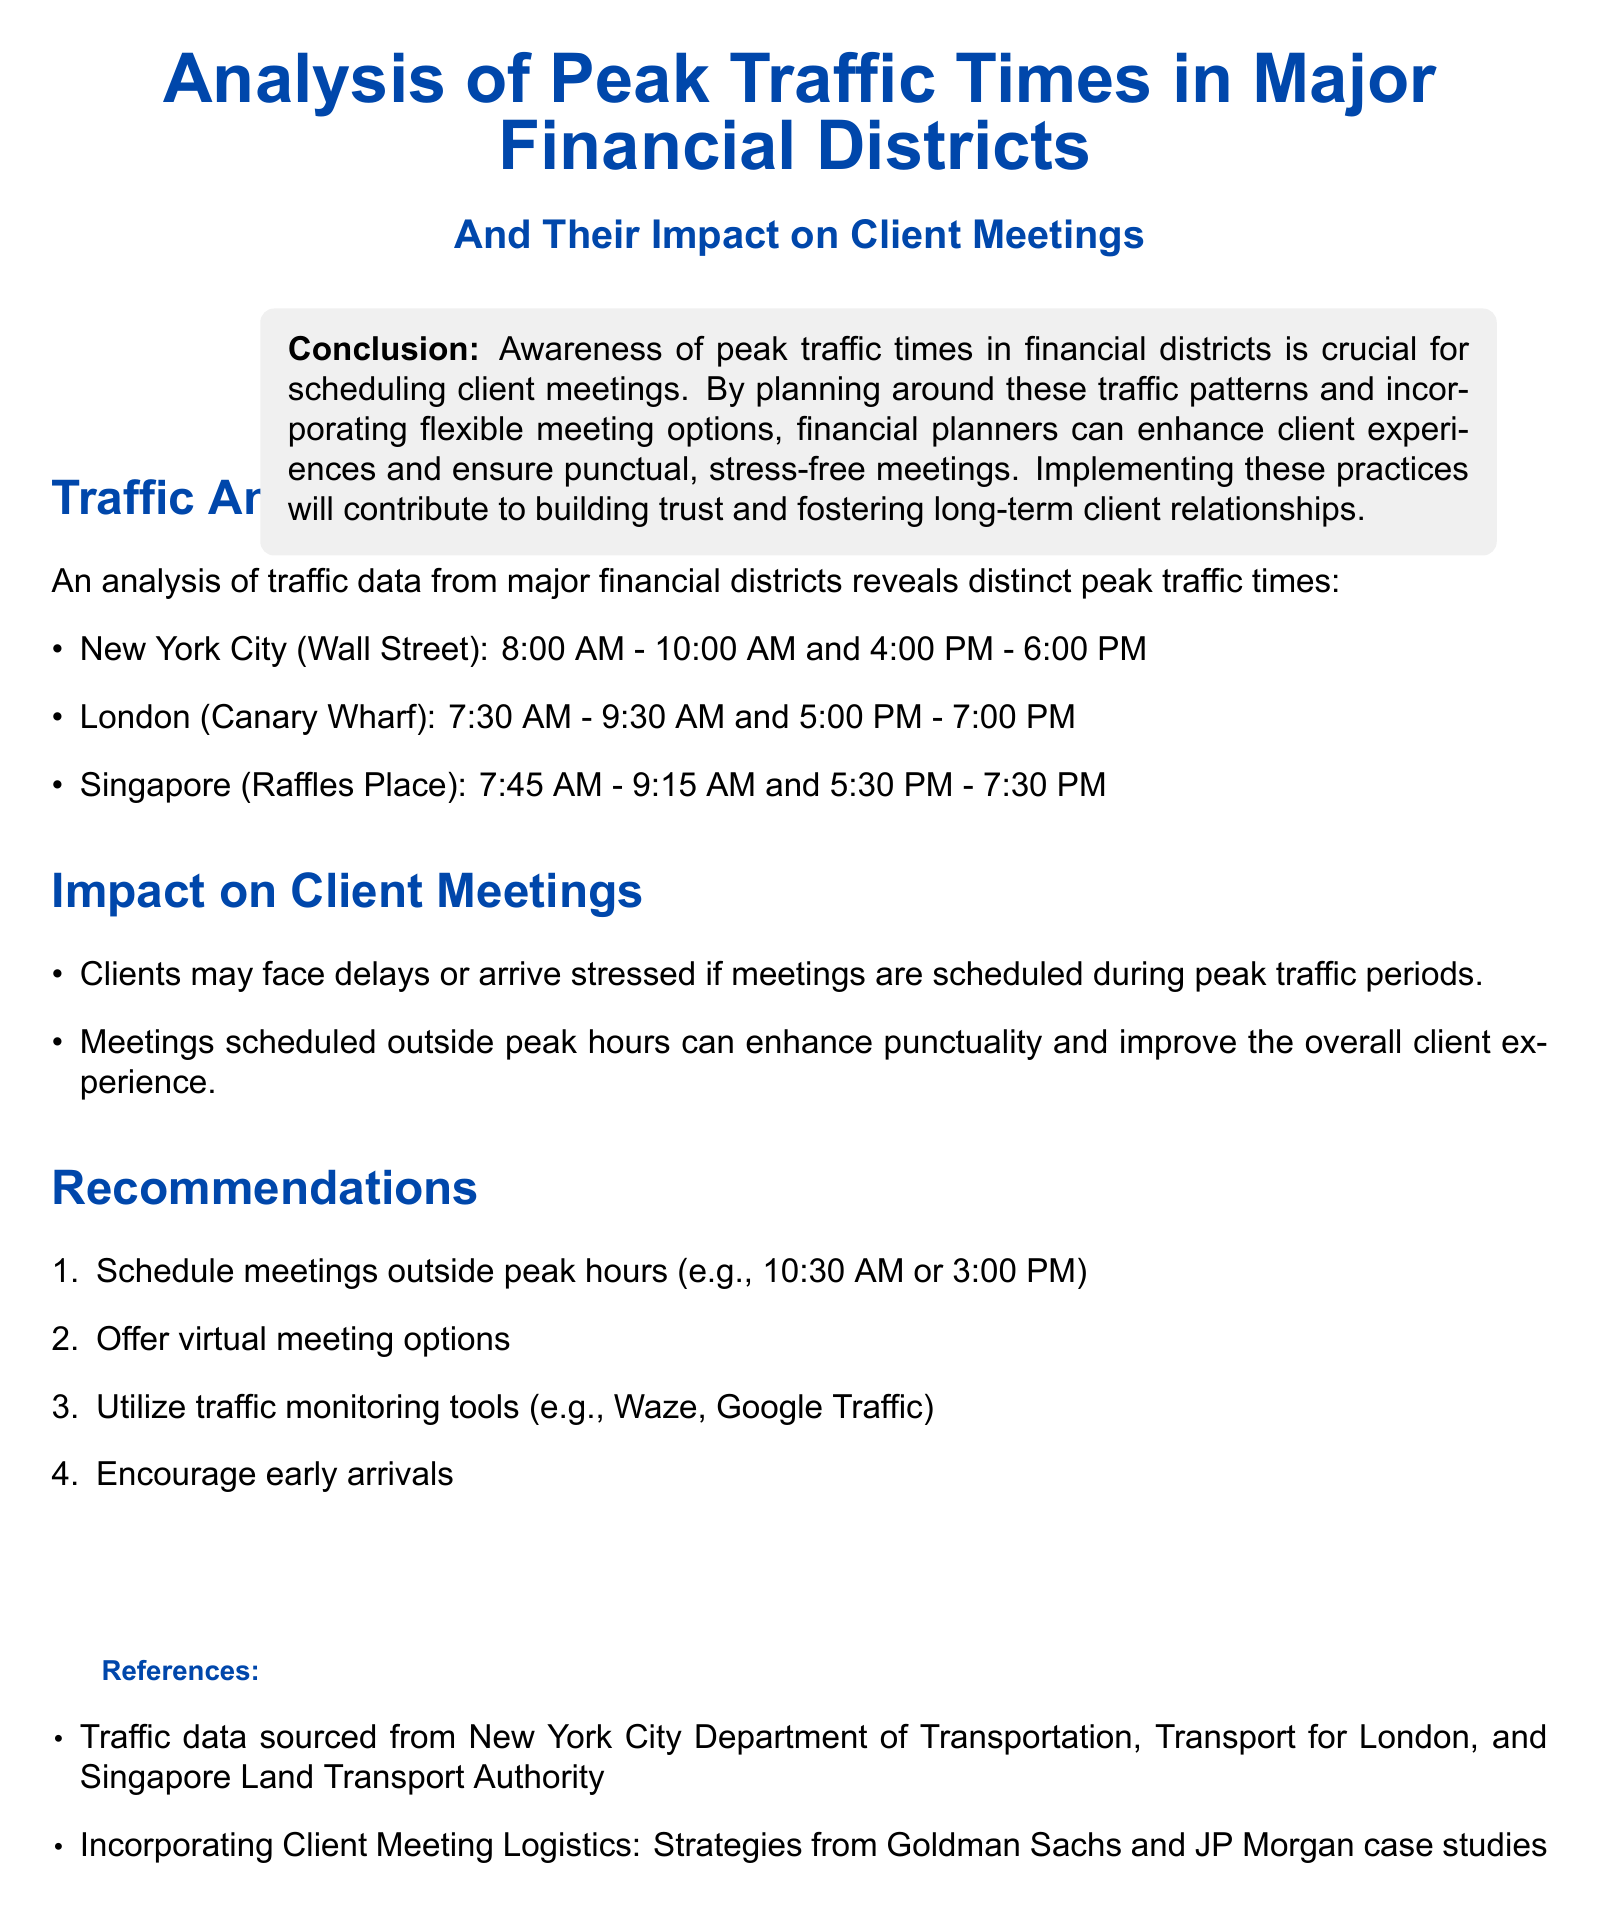What are the peak traffic times for New York City? The peak traffic times for New York City (Wall Street) are stated in the document as 8:00 AM - 10:00 AM and 4:00 PM - 6:00 PM.
Answer: 8:00 AM - 10:00 AM and 4:00 PM - 6:00 PM Which financial district has peak traffic from 7:30 AM to 9:30 AM? The document specifies the peak traffic times for London (Canary Wharf) as 7:30 AM - 9:30 AM and 5:00 PM - 7:00 PM.
Answer: London (Canary Wharf) What is one impact of scheduling client meetings during peak traffic times? The document lists various impacts, including that clients may face delays or arrive stressed.
Answer: Delays or stressed arrival What time does the document recommend for scheduling meetings? The document suggests specific times for scheduling meetings outside peak traffic hours, such as 10:30 AM or 3:00 PM.
Answer: 10:30 AM or 3:00 PM What is the conclusion regarding awareness of peak traffic times? The document concludes that awareness of peak traffic times is crucial for scheduling client meetings, impacting overall experiences.
Answer: Crucial for scheduling What tools does the report recommend for monitoring traffic? The report mentions utilizing traffic monitoring tools such as Waze and Google Traffic for better meeting planning.
Answer: Waze, Google Traffic 